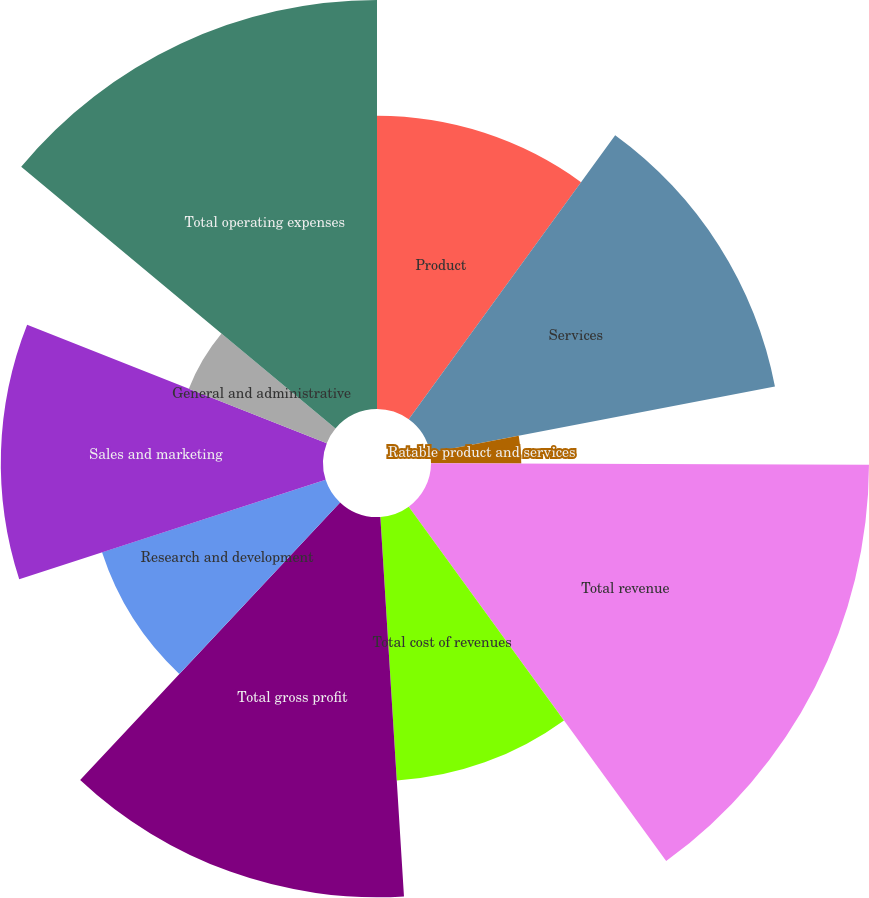<chart> <loc_0><loc_0><loc_500><loc_500><pie_chart><fcel>Product<fcel>Services<fcel>Ratable product and services<fcel>Total revenue<fcel>Total cost of revenues<fcel>Total gross profit<fcel>Research and development<fcel>Sales and marketing<fcel>General and administrative<fcel>Total operating expenses<nl><fcel>10.0%<fcel>11.98%<fcel>3.08%<fcel>14.94%<fcel>9.01%<fcel>12.97%<fcel>8.02%<fcel>10.99%<fcel>5.06%<fcel>13.95%<nl></chart> 